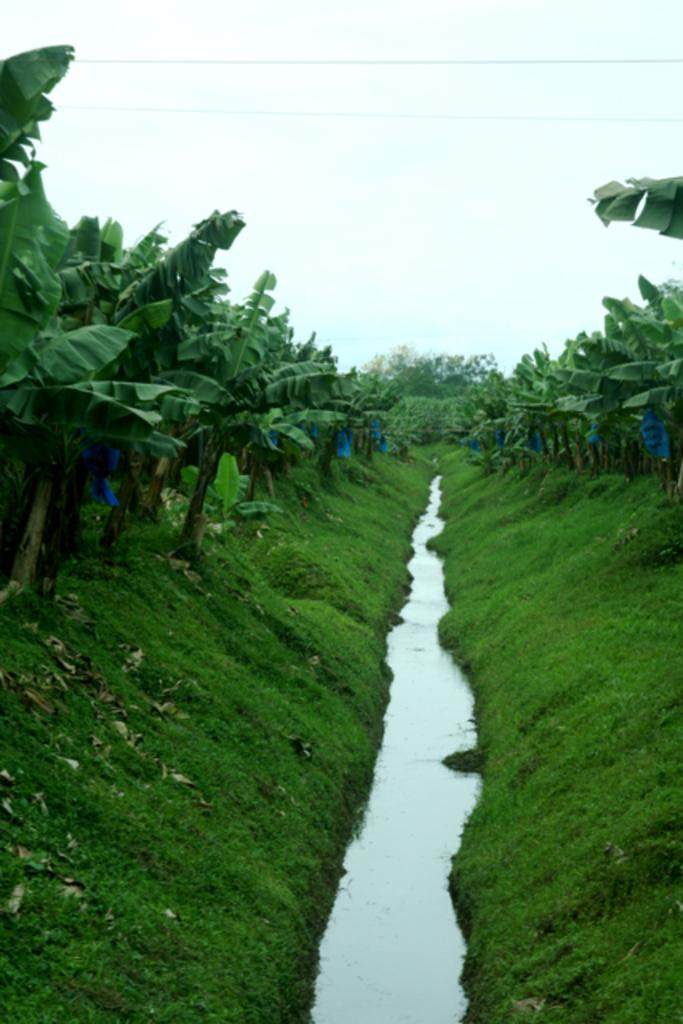What type of vegetation can be seen in the image? There are trees and grass in the image. What natural element is visible in the image? Water is visible in the image. What else can be found on the ground in the image? There are leaves in the image. What can be seen in the background of the image? The sky is visible in the background of the image. How many chairs are visible in the image? There are no chairs present in the image. What time of day is depicted in the image? The time of day cannot be determined from the image, as there are no specific indicators of time. 